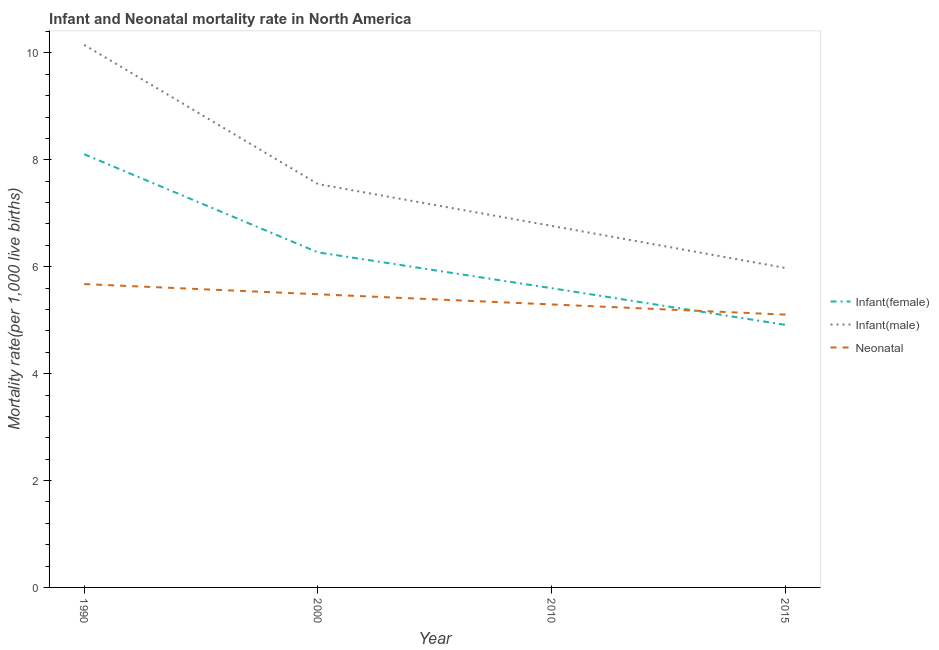How many different coloured lines are there?
Ensure brevity in your answer.  3. Does the line corresponding to infant mortality rate(female) intersect with the line corresponding to neonatal mortality rate?
Your answer should be compact. Yes. What is the infant mortality rate(male) in 1990?
Ensure brevity in your answer.  10.15. Across all years, what is the maximum infant mortality rate(female)?
Offer a terse response. 8.11. Across all years, what is the minimum neonatal mortality rate?
Make the answer very short. 5.1. In which year was the infant mortality rate(male) maximum?
Your answer should be very brief. 1990. In which year was the infant mortality rate(male) minimum?
Offer a terse response. 2015. What is the total infant mortality rate(male) in the graph?
Make the answer very short. 30.44. What is the difference between the infant mortality rate(female) in 2000 and that in 2015?
Offer a very short reply. 1.36. What is the difference between the infant mortality rate(male) in 2015 and the infant mortality rate(female) in 2010?
Make the answer very short. 0.38. What is the average neonatal mortality rate per year?
Make the answer very short. 5.39. In the year 1990, what is the difference between the infant mortality rate(male) and infant mortality rate(female)?
Your response must be concise. 2.05. In how many years, is the infant mortality rate(male) greater than 6.4?
Keep it short and to the point. 3. What is the ratio of the infant mortality rate(female) in 1990 to that in 2010?
Your answer should be very brief. 1.45. What is the difference between the highest and the second highest infant mortality rate(male)?
Your answer should be very brief. 2.61. What is the difference between the highest and the lowest infant mortality rate(male)?
Your answer should be very brief. 4.17. In how many years, is the infant mortality rate(female) greater than the average infant mortality rate(female) taken over all years?
Make the answer very short. 2. Is the sum of the infant mortality rate(female) in 1990 and 2010 greater than the maximum neonatal mortality rate across all years?
Your answer should be compact. Yes. Is it the case that in every year, the sum of the infant mortality rate(female) and infant mortality rate(male) is greater than the neonatal mortality rate?
Provide a succinct answer. Yes. Is the infant mortality rate(female) strictly greater than the neonatal mortality rate over the years?
Provide a succinct answer. No. How many lines are there?
Give a very brief answer. 3. How many years are there in the graph?
Your answer should be compact. 4. What is the difference between two consecutive major ticks on the Y-axis?
Provide a short and direct response. 2. Does the graph contain grids?
Offer a terse response. No. Where does the legend appear in the graph?
Give a very brief answer. Center right. How are the legend labels stacked?
Ensure brevity in your answer.  Vertical. What is the title of the graph?
Offer a terse response. Infant and Neonatal mortality rate in North America. What is the label or title of the X-axis?
Provide a succinct answer. Year. What is the label or title of the Y-axis?
Provide a short and direct response. Mortality rate(per 1,0 live births). What is the Mortality rate(per 1,000 live births) in Infant(female) in 1990?
Offer a terse response. 8.11. What is the Mortality rate(per 1,000 live births) in Infant(male) in 1990?
Offer a very short reply. 10.15. What is the Mortality rate(per 1,000 live births) of Neonatal  in 1990?
Your answer should be compact. 5.68. What is the Mortality rate(per 1,000 live births) of Infant(female) in 2000?
Make the answer very short. 6.27. What is the Mortality rate(per 1,000 live births) of Infant(male) in 2000?
Give a very brief answer. 7.55. What is the Mortality rate(per 1,000 live births) in Neonatal  in 2000?
Provide a short and direct response. 5.49. What is the Mortality rate(per 1,000 live births) of Infant(female) in 2010?
Ensure brevity in your answer.  5.6. What is the Mortality rate(per 1,000 live births) of Infant(male) in 2010?
Offer a very short reply. 6.76. What is the Mortality rate(per 1,000 live births) of Neonatal  in 2010?
Provide a succinct answer. 5.29. What is the Mortality rate(per 1,000 live births) in Infant(female) in 2015?
Offer a very short reply. 4.91. What is the Mortality rate(per 1,000 live births) in Infant(male) in 2015?
Provide a succinct answer. 5.98. What is the Mortality rate(per 1,000 live births) of Neonatal  in 2015?
Your answer should be compact. 5.1. Across all years, what is the maximum Mortality rate(per 1,000 live births) in Infant(female)?
Ensure brevity in your answer.  8.11. Across all years, what is the maximum Mortality rate(per 1,000 live births) in Infant(male)?
Make the answer very short. 10.15. Across all years, what is the maximum Mortality rate(per 1,000 live births) in Neonatal ?
Offer a very short reply. 5.68. Across all years, what is the minimum Mortality rate(per 1,000 live births) in Infant(female)?
Make the answer very short. 4.91. Across all years, what is the minimum Mortality rate(per 1,000 live births) of Infant(male)?
Ensure brevity in your answer.  5.98. Across all years, what is the minimum Mortality rate(per 1,000 live births) of Neonatal ?
Your response must be concise. 5.1. What is the total Mortality rate(per 1,000 live births) in Infant(female) in the graph?
Offer a terse response. 24.89. What is the total Mortality rate(per 1,000 live births) of Infant(male) in the graph?
Keep it short and to the point. 30.44. What is the total Mortality rate(per 1,000 live births) in Neonatal  in the graph?
Your answer should be compact. 21.56. What is the difference between the Mortality rate(per 1,000 live births) of Infant(female) in 1990 and that in 2000?
Your answer should be compact. 1.84. What is the difference between the Mortality rate(per 1,000 live births) of Infant(male) in 1990 and that in 2000?
Provide a succinct answer. 2.61. What is the difference between the Mortality rate(per 1,000 live births) in Neonatal  in 1990 and that in 2000?
Offer a very short reply. 0.19. What is the difference between the Mortality rate(per 1,000 live births) of Infant(female) in 1990 and that in 2010?
Your response must be concise. 2.51. What is the difference between the Mortality rate(per 1,000 live births) in Infant(male) in 1990 and that in 2010?
Make the answer very short. 3.39. What is the difference between the Mortality rate(per 1,000 live births) of Neonatal  in 1990 and that in 2010?
Your answer should be compact. 0.38. What is the difference between the Mortality rate(per 1,000 live births) of Infant(female) in 1990 and that in 2015?
Provide a succinct answer. 3.19. What is the difference between the Mortality rate(per 1,000 live births) of Infant(male) in 1990 and that in 2015?
Offer a very short reply. 4.17. What is the difference between the Mortality rate(per 1,000 live births) in Neonatal  in 1990 and that in 2015?
Ensure brevity in your answer.  0.57. What is the difference between the Mortality rate(per 1,000 live births) of Infant(female) in 2000 and that in 2010?
Your answer should be compact. 0.67. What is the difference between the Mortality rate(per 1,000 live births) of Infant(male) in 2000 and that in 2010?
Ensure brevity in your answer.  0.78. What is the difference between the Mortality rate(per 1,000 live births) of Neonatal  in 2000 and that in 2010?
Give a very brief answer. 0.19. What is the difference between the Mortality rate(per 1,000 live births) in Infant(female) in 2000 and that in 2015?
Provide a succinct answer. 1.36. What is the difference between the Mortality rate(per 1,000 live births) of Infant(male) in 2000 and that in 2015?
Your answer should be compact. 1.57. What is the difference between the Mortality rate(per 1,000 live births) of Neonatal  in 2000 and that in 2015?
Keep it short and to the point. 0.38. What is the difference between the Mortality rate(per 1,000 live births) of Infant(female) in 2010 and that in 2015?
Your answer should be very brief. 0.69. What is the difference between the Mortality rate(per 1,000 live births) of Infant(male) in 2010 and that in 2015?
Offer a terse response. 0.79. What is the difference between the Mortality rate(per 1,000 live births) of Neonatal  in 2010 and that in 2015?
Offer a terse response. 0.19. What is the difference between the Mortality rate(per 1,000 live births) in Infant(female) in 1990 and the Mortality rate(per 1,000 live births) in Infant(male) in 2000?
Your response must be concise. 0.56. What is the difference between the Mortality rate(per 1,000 live births) of Infant(female) in 1990 and the Mortality rate(per 1,000 live births) of Neonatal  in 2000?
Ensure brevity in your answer.  2.62. What is the difference between the Mortality rate(per 1,000 live births) of Infant(male) in 1990 and the Mortality rate(per 1,000 live births) of Neonatal  in 2000?
Give a very brief answer. 4.67. What is the difference between the Mortality rate(per 1,000 live births) in Infant(female) in 1990 and the Mortality rate(per 1,000 live births) in Infant(male) in 2010?
Provide a short and direct response. 1.34. What is the difference between the Mortality rate(per 1,000 live births) in Infant(female) in 1990 and the Mortality rate(per 1,000 live births) in Neonatal  in 2010?
Provide a short and direct response. 2.81. What is the difference between the Mortality rate(per 1,000 live births) in Infant(male) in 1990 and the Mortality rate(per 1,000 live births) in Neonatal  in 2010?
Offer a very short reply. 4.86. What is the difference between the Mortality rate(per 1,000 live births) in Infant(female) in 1990 and the Mortality rate(per 1,000 live births) in Infant(male) in 2015?
Make the answer very short. 2.13. What is the difference between the Mortality rate(per 1,000 live births) in Infant(female) in 1990 and the Mortality rate(per 1,000 live births) in Neonatal  in 2015?
Provide a short and direct response. 3. What is the difference between the Mortality rate(per 1,000 live births) of Infant(male) in 1990 and the Mortality rate(per 1,000 live births) of Neonatal  in 2015?
Offer a very short reply. 5.05. What is the difference between the Mortality rate(per 1,000 live births) of Infant(female) in 2000 and the Mortality rate(per 1,000 live births) of Infant(male) in 2010?
Your response must be concise. -0.5. What is the difference between the Mortality rate(per 1,000 live births) of Infant(female) in 2000 and the Mortality rate(per 1,000 live births) of Neonatal  in 2010?
Offer a very short reply. 0.97. What is the difference between the Mortality rate(per 1,000 live births) of Infant(male) in 2000 and the Mortality rate(per 1,000 live births) of Neonatal  in 2010?
Keep it short and to the point. 2.25. What is the difference between the Mortality rate(per 1,000 live births) of Infant(female) in 2000 and the Mortality rate(per 1,000 live births) of Infant(male) in 2015?
Your answer should be compact. 0.29. What is the difference between the Mortality rate(per 1,000 live births) of Infant(female) in 2000 and the Mortality rate(per 1,000 live births) of Neonatal  in 2015?
Make the answer very short. 1.17. What is the difference between the Mortality rate(per 1,000 live births) of Infant(male) in 2000 and the Mortality rate(per 1,000 live births) of Neonatal  in 2015?
Your response must be concise. 2.44. What is the difference between the Mortality rate(per 1,000 live births) in Infant(female) in 2010 and the Mortality rate(per 1,000 live births) in Infant(male) in 2015?
Offer a very short reply. -0.38. What is the difference between the Mortality rate(per 1,000 live births) in Infant(female) in 2010 and the Mortality rate(per 1,000 live births) in Neonatal  in 2015?
Offer a terse response. 0.49. What is the difference between the Mortality rate(per 1,000 live births) of Infant(male) in 2010 and the Mortality rate(per 1,000 live births) of Neonatal  in 2015?
Keep it short and to the point. 1.66. What is the average Mortality rate(per 1,000 live births) in Infant(female) per year?
Your response must be concise. 6.22. What is the average Mortality rate(per 1,000 live births) in Infant(male) per year?
Keep it short and to the point. 7.61. What is the average Mortality rate(per 1,000 live births) of Neonatal  per year?
Offer a terse response. 5.39. In the year 1990, what is the difference between the Mortality rate(per 1,000 live births) of Infant(female) and Mortality rate(per 1,000 live births) of Infant(male)?
Give a very brief answer. -2.05. In the year 1990, what is the difference between the Mortality rate(per 1,000 live births) in Infant(female) and Mortality rate(per 1,000 live births) in Neonatal ?
Your answer should be compact. 2.43. In the year 1990, what is the difference between the Mortality rate(per 1,000 live births) in Infant(male) and Mortality rate(per 1,000 live births) in Neonatal ?
Ensure brevity in your answer.  4.48. In the year 2000, what is the difference between the Mortality rate(per 1,000 live births) of Infant(female) and Mortality rate(per 1,000 live births) of Infant(male)?
Give a very brief answer. -1.28. In the year 2000, what is the difference between the Mortality rate(per 1,000 live births) in Infant(female) and Mortality rate(per 1,000 live births) in Neonatal ?
Offer a terse response. 0.78. In the year 2000, what is the difference between the Mortality rate(per 1,000 live births) of Infant(male) and Mortality rate(per 1,000 live births) of Neonatal ?
Give a very brief answer. 2.06. In the year 2010, what is the difference between the Mortality rate(per 1,000 live births) in Infant(female) and Mortality rate(per 1,000 live births) in Infant(male)?
Offer a terse response. -1.17. In the year 2010, what is the difference between the Mortality rate(per 1,000 live births) in Infant(female) and Mortality rate(per 1,000 live births) in Neonatal ?
Ensure brevity in your answer.  0.3. In the year 2010, what is the difference between the Mortality rate(per 1,000 live births) of Infant(male) and Mortality rate(per 1,000 live births) of Neonatal ?
Make the answer very short. 1.47. In the year 2015, what is the difference between the Mortality rate(per 1,000 live births) in Infant(female) and Mortality rate(per 1,000 live births) in Infant(male)?
Offer a terse response. -1.06. In the year 2015, what is the difference between the Mortality rate(per 1,000 live births) in Infant(female) and Mortality rate(per 1,000 live births) in Neonatal ?
Keep it short and to the point. -0.19. In the year 2015, what is the difference between the Mortality rate(per 1,000 live births) in Infant(male) and Mortality rate(per 1,000 live births) in Neonatal ?
Keep it short and to the point. 0.87. What is the ratio of the Mortality rate(per 1,000 live births) of Infant(female) in 1990 to that in 2000?
Keep it short and to the point. 1.29. What is the ratio of the Mortality rate(per 1,000 live births) in Infant(male) in 1990 to that in 2000?
Your answer should be very brief. 1.35. What is the ratio of the Mortality rate(per 1,000 live births) of Neonatal  in 1990 to that in 2000?
Keep it short and to the point. 1.03. What is the ratio of the Mortality rate(per 1,000 live births) in Infant(female) in 1990 to that in 2010?
Your response must be concise. 1.45. What is the ratio of the Mortality rate(per 1,000 live births) of Infant(male) in 1990 to that in 2010?
Offer a very short reply. 1.5. What is the ratio of the Mortality rate(per 1,000 live births) of Neonatal  in 1990 to that in 2010?
Give a very brief answer. 1.07. What is the ratio of the Mortality rate(per 1,000 live births) of Infant(female) in 1990 to that in 2015?
Offer a very short reply. 1.65. What is the ratio of the Mortality rate(per 1,000 live births) of Infant(male) in 1990 to that in 2015?
Give a very brief answer. 1.7. What is the ratio of the Mortality rate(per 1,000 live births) of Neonatal  in 1990 to that in 2015?
Offer a terse response. 1.11. What is the ratio of the Mortality rate(per 1,000 live births) of Infant(female) in 2000 to that in 2010?
Offer a terse response. 1.12. What is the ratio of the Mortality rate(per 1,000 live births) in Infant(male) in 2000 to that in 2010?
Provide a succinct answer. 1.12. What is the ratio of the Mortality rate(per 1,000 live births) in Neonatal  in 2000 to that in 2010?
Your answer should be very brief. 1.04. What is the ratio of the Mortality rate(per 1,000 live births) in Infant(female) in 2000 to that in 2015?
Offer a very short reply. 1.28. What is the ratio of the Mortality rate(per 1,000 live births) in Infant(male) in 2000 to that in 2015?
Your answer should be very brief. 1.26. What is the ratio of the Mortality rate(per 1,000 live births) of Neonatal  in 2000 to that in 2015?
Ensure brevity in your answer.  1.07. What is the ratio of the Mortality rate(per 1,000 live births) in Infant(female) in 2010 to that in 2015?
Your answer should be very brief. 1.14. What is the ratio of the Mortality rate(per 1,000 live births) of Infant(male) in 2010 to that in 2015?
Provide a succinct answer. 1.13. What is the ratio of the Mortality rate(per 1,000 live births) in Neonatal  in 2010 to that in 2015?
Make the answer very short. 1.04. What is the difference between the highest and the second highest Mortality rate(per 1,000 live births) in Infant(female)?
Make the answer very short. 1.84. What is the difference between the highest and the second highest Mortality rate(per 1,000 live births) of Infant(male)?
Make the answer very short. 2.61. What is the difference between the highest and the second highest Mortality rate(per 1,000 live births) in Neonatal ?
Your answer should be compact. 0.19. What is the difference between the highest and the lowest Mortality rate(per 1,000 live births) in Infant(female)?
Give a very brief answer. 3.19. What is the difference between the highest and the lowest Mortality rate(per 1,000 live births) in Infant(male)?
Offer a very short reply. 4.17. What is the difference between the highest and the lowest Mortality rate(per 1,000 live births) of Neonatal ?
Ensure brevity in your answer.  0.57. 